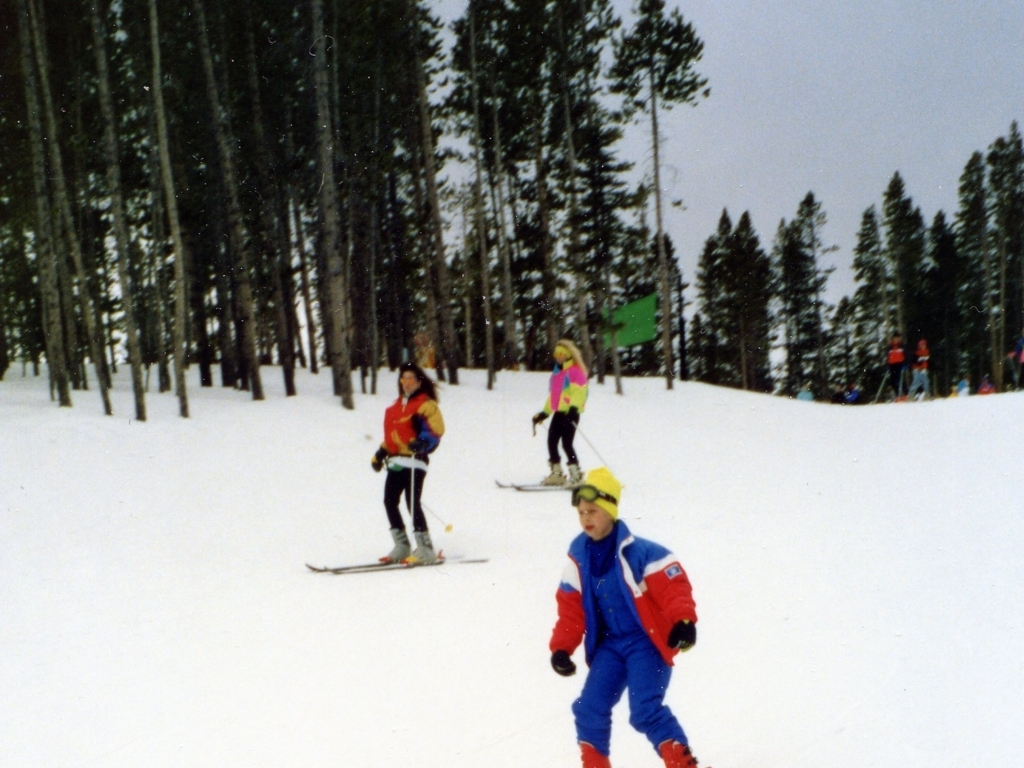Is there any distortion in the image?
A. No
B. Yes
Answer with the option's letter from the given choices directly.
 A. 